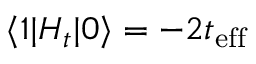<formula> <loc_0><loc_0><loc_500><loc_500>\langle 1 | H _ { t } | 0 \rangle = - 2 t _ { e f f }</formula> 